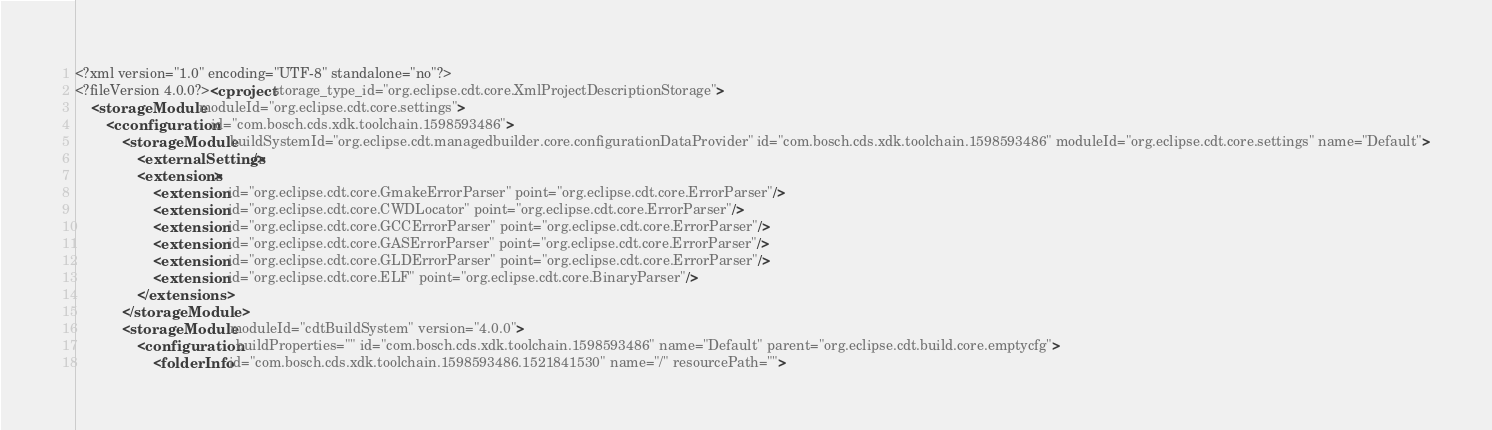Convert code to text. <code><loc_0><loc_0><loc_500><loc_500><_XML_><?xml version="1.0" encoding="UTF-8" standalone="no"?>
<?fileVersion 4.0.0?><cproject storage_type_id="org.eclipse.cdt.core.XmlProjectDescriptionStorage">
	<storageModule moduleId="org.eclipse.cdt.core.settings">
		<cconfiguration id="com.bosch.cds.xdk.toolchain.1598593486">
			<storageModule buildSystemId="org.eclipse.cdt.managedbuilder.core.configurationDataProvider" id="com.bosch.cds.xdk.toolchain.1598593486" moduleId="org.eclipse.cdt.core.settings" name="Default">
				<externalSettings/>
				<extensions>
					<extension id="org.eclipse.cdt.core.GmakeErrorParser" point="org.eclipse.cdt.core.ErrorParser"/>
					<extension id="org.eclipse.cdt.core.CWDLocator" point="org.eclipse.cdt.core.ErrorParser"/>
					<extension id="org.eclipse.cdt.core.GCCErrorParser" point="org.eclipse.cdt.core.ErrorParser"/>
					<extension id="org.eclipse.cdt.core.GASErrorParser" point="org.eclipse.cdt.core.ErrorParser"/>
					<extension id="org.eclipse.cdt.core.GLDErrorParser" point="org.eclipse.cdt.core.ErrorParser"/>
					<extension id="org.eclipse.cdt.core.ELF" point="org.eclipse.cdt.core.BinaryParser"/>
				</extensions>
			</storageModule>
			<storageModule moduleId="cdtBuildSystem" version="4.0.0">
				<configuration buildProperties="" id="com.bosch.cds.xdk.toolchain.1598593486" name="Default" parent="org.eclipse.cdt.build.core.emptycfg">
					<folderInfo id="com.bosch.cds.xdk.toolchain.1598593486.1521841530" name="/" resourcePath=""></code> 